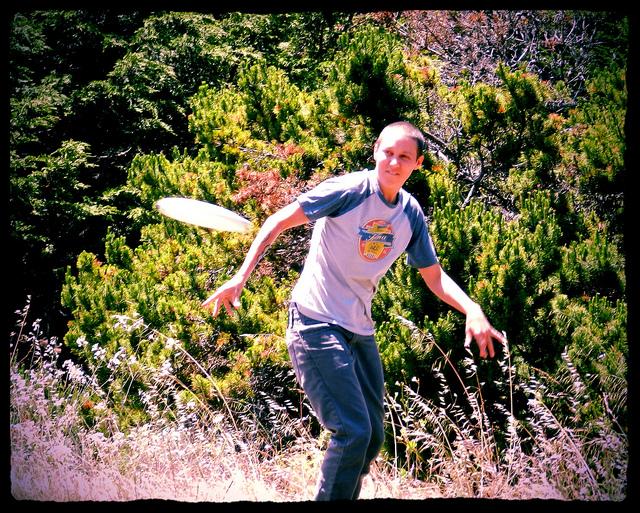Are they playing baseball?
Short answer required. No. Is his shirt all one color?
Concise answer only. No. Where is the young man playing Frisbee?
Give a very brief answer. Outside. 